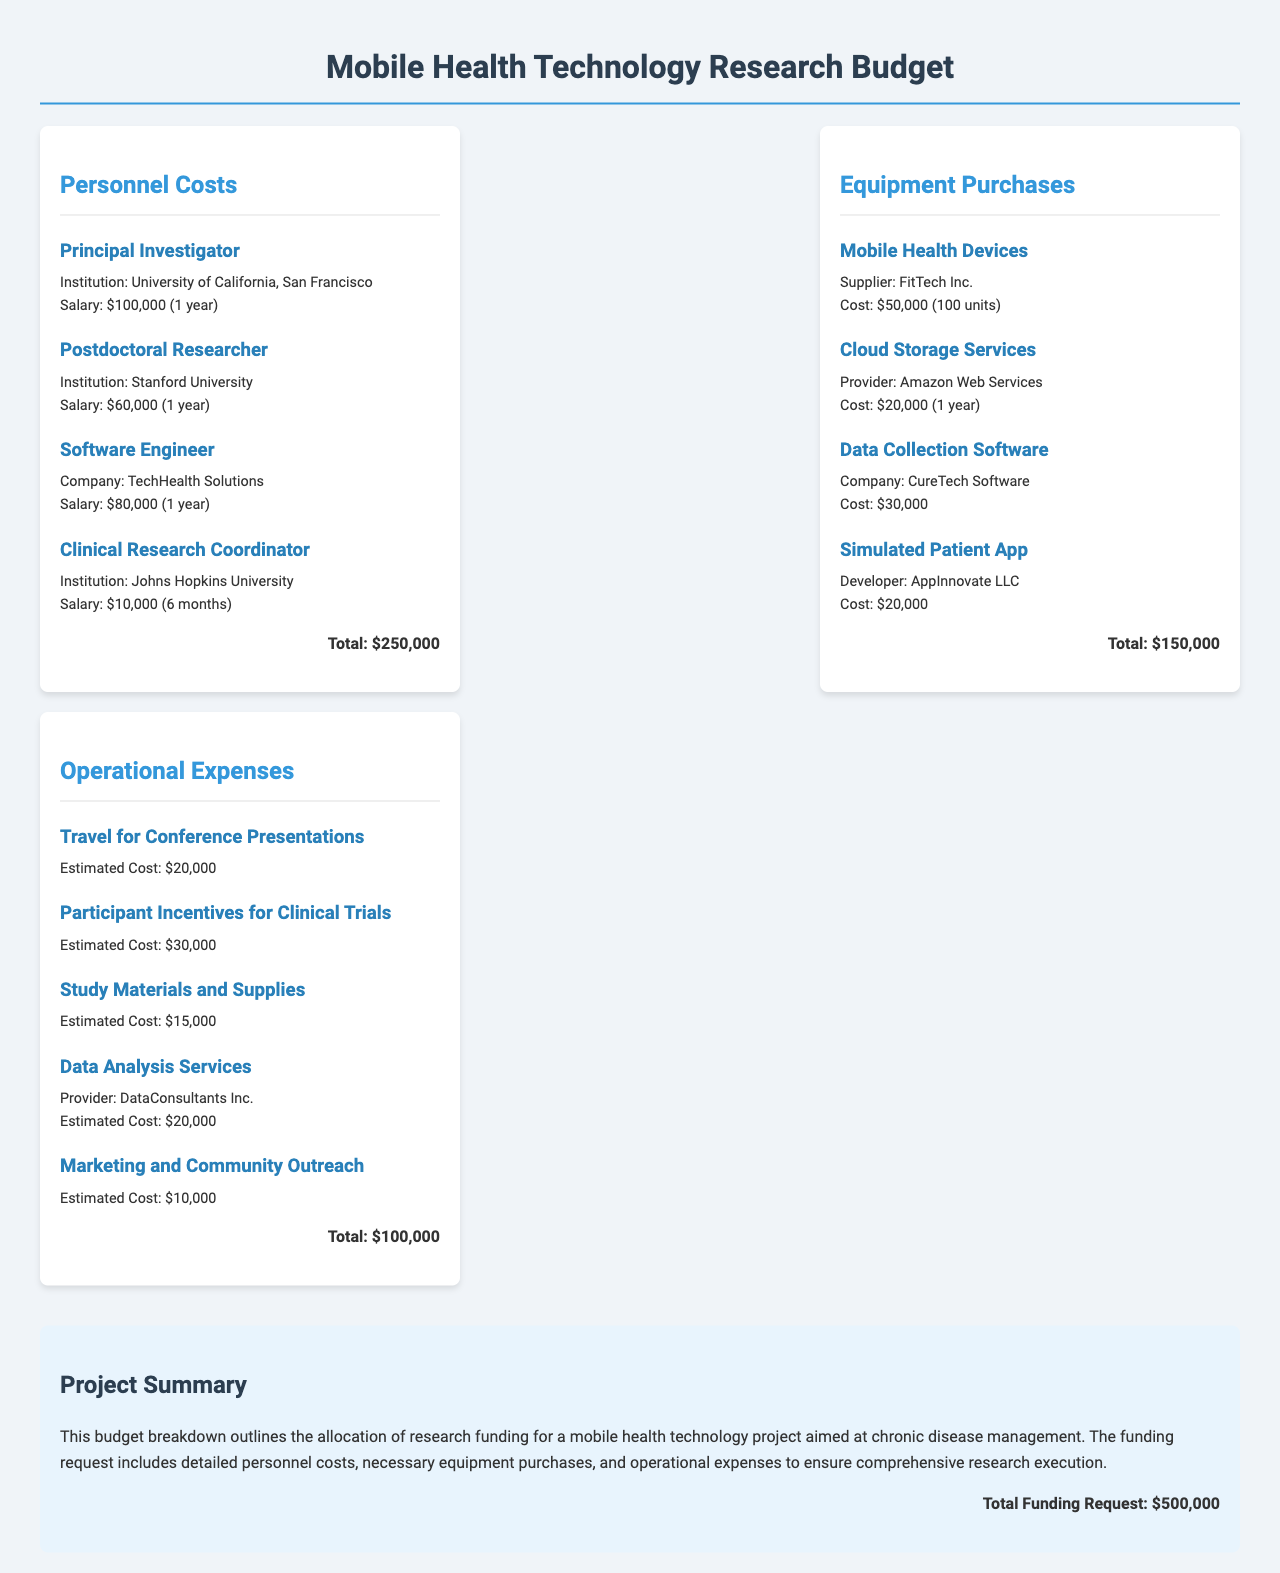What is the total funding request? The total funding request is mentioned in the summary section of the document.
Answer: $500,000 Who is the Principal Investigator? The Principal Investigator’s institution is listed in the Personnel Costs section.
Answer: University of California, San Francisco What is the cost of mobile health devices? The cost of mobile health devices is provided in the Equipment Purchases section.
Answer: $50,000 How much is allocated for Participant Incentives for Clinical Trials? The amount for Participant Incentives is mentioned under Operational Expenses.
Answer: $30,000 Which company is providing the Data Analysis Services? The provider of Data Analysis Services is listed in the Operational Expenses section.
Answer: DataConsultants Inc What is the salary of the Postdoctoral Researcher? The salary for the Postdoctoral Researcher is included in the Personnel Costs section.
Answer: $60,000 What is the total amount allocated for Equipment Purchases? The total for Equipment Purchases is found at the bottom of that section.
Answer: $150,000 How long is the Clinical Research Coordinator's contract? The duration of the Clinical Research Coordinator’s contract is specified in the Personnel Costs section.
Answer: 6 months What is the estimated cost for Data Collection Software? The estimated cost is detailed in the Equipment Purchases section of the document.
Answer: $30,000 